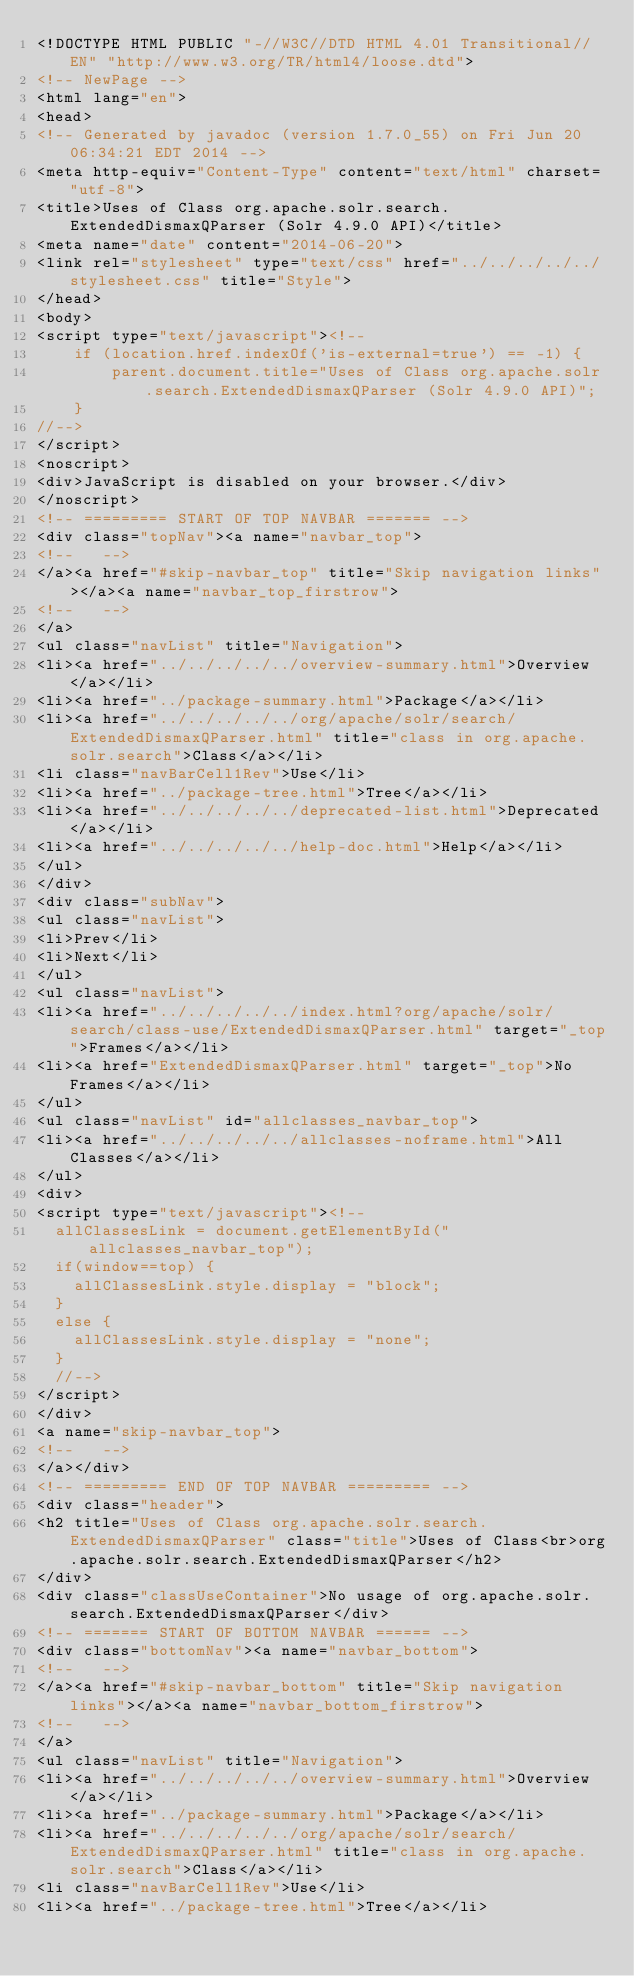Convert code to text. <code><loc_0><loc_0><loc_500><loc_500><_HTML_><!DOCTYPE HTML PUBLIC "-//W3C//DTD HTML 4.01 Transitional//EN" "http://www.w3.org/TR/html4/loose.dtd">
<!-- NewPage -->
<html lang="en">
<head>
<!-- Generated by javadoc (version 1.7.0_55) on Fri Jun 20 06:34:21 EDT 2014 -->
<meta http-equiv="Content-Type" content="text/html" charset="utf-8">
<title>Uses of Class org.apache.solr.search.ExtendedDismaxQParser (Solr 4.9.0 API)</title>
<meta name="date" content="2014-06-20">
<link rel="stylesheet" type="text/css" href="../../../../../stylesheet.css" title="Style">
</head>
<body>
<script type="text/javascript"><!--
    if (location.href.indexOf('is-external=true') == -1) {
        parent.document.title="Uses of Class org.apache.solr.search.ExtendedDismaxQParser (Solr 4.9.0 API)";
    }
//-->
</script>
<noscript>
<div>JavaScript is disabled on your browser.</div>
</noscript>
<!-- ========= START OF TOP NAVBAR ======= -->
<div class="topNav"><a name="navbar_top">
<!--   -->
</a><a href="#skip-navbar_top" title="Skip navigation links"></a><a name="navbar_top_firstrow">
<!--   -->
</a>
<ul class="navList" title="Navigation">
<li><a href="../../../../../overview-summary.html">Overview</a></li>
<li><a href="../package-summary.html">Package</a></li>
<li><a href="../../../../../org/apache/solr/search/ExtendedDismaxQParser.html" title="class in org.apache.solr.search">Class</a></li>
<li class="navBarCell1Rev">Use</li>
<li><a href="../package-tree.html">Tree</a></li>
<li><a href="../../../../../deprecated-list.html">Deprecated</a></li>
<li><a href="../../../../../help-doc.html">Help</a></li>
</ul>
</div>
<div class="subNav">
<ul class="navList">
<li>Prev</li>
<li>Next</li>
</ul>
<ul class="navList">
<li><a href="../../../../../index.html?org/apache/solr/search/class-use/ExtendedDismaxQParser.html" target="_top">Frames</a></li>
<li><a href="ExtendedDismaxQParser.html" target="_top">No Frames</a></li>
</ul>
<ul class="navList" id="allclasses_navbar_top">
<li><a href="../../../../../allclasses-noframe.html">All Classes</a></li>
</ul>
<div>
<script type="text/javascript"><!--
  allClassesLink = document.getElementById("allclasses_navbar_top");
  if(window==top) {
    allClassesLink.style.display = "block";
  }
  else {
    allClassesLink.style.display = "none";
  }
  //-->
</script>
</div>
<a name="skip-navbar_top">
<!--   -->
</a></div>
<!-- ========= END OF TOP NAVBAR ========= -->
<div class="header">
<h2 title="Uses of Class org.apache.solr.search.ExtendedDismaxQParser" class="title">Uses of Class<br>org.apache.solr.search.ExtendedDismaxQParser</h2>
</div>
<div class="classUseContainer">No usage of org.apache.solr.search.ExtendedDismaxQParser</div>
<!-- ======= START OF BOTTOM NAVBAR ====== -->
<div class="bottomNav"><a name="navbar_bottom">
<!--   -->
</a><a href="#skip-navbar_bottom" title="Skip navigation links"></a><a name="navbar_bottom_firstrow">
<!--   -->
</a>
<ul class="navList" title="Navigation">
<li><a href="../../../../../overview-summary.html">Overview</a></li>
<li><a href="../package-summary.html">Package</a></li>
<li><a href="../../../../../org/apache/solr/search/ExtendedDismaxQParser.html" title="class in org.apache.solr.search">Class</a></li>
<li class="navBarCell1Rev">Use</li>
<li><a href="../package-tree.html">Tree</a></li></code> 